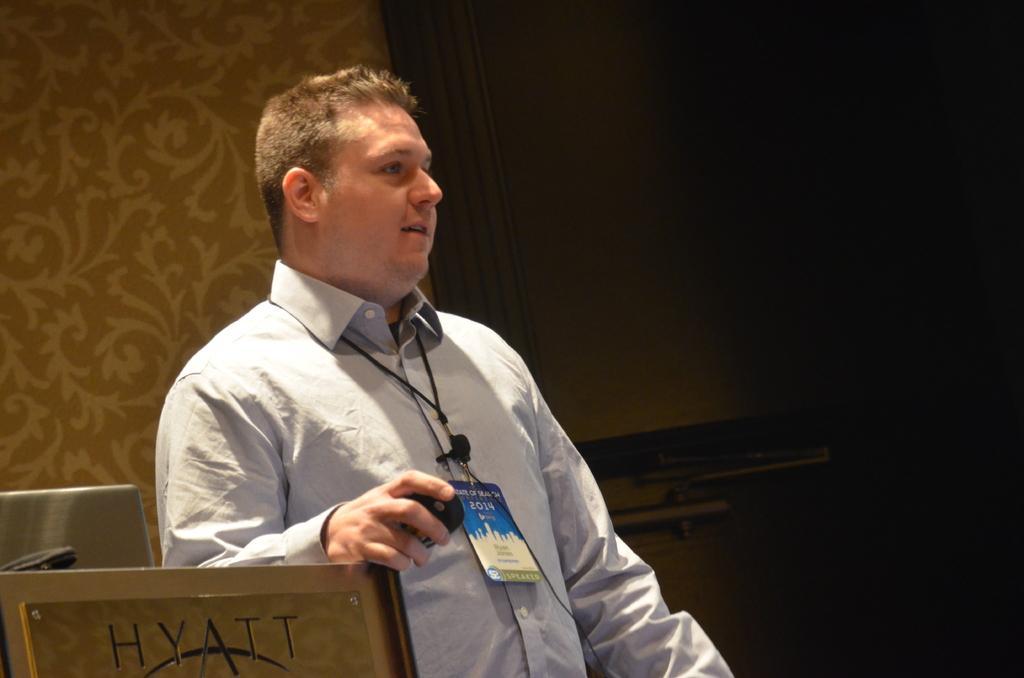Could you give a brief overview of what you see in this image? In this image there is a person standing by holding an object in his hand, beside the person there is a podium, behind the person there is a laptop and some object and there is a wall with a screen. 